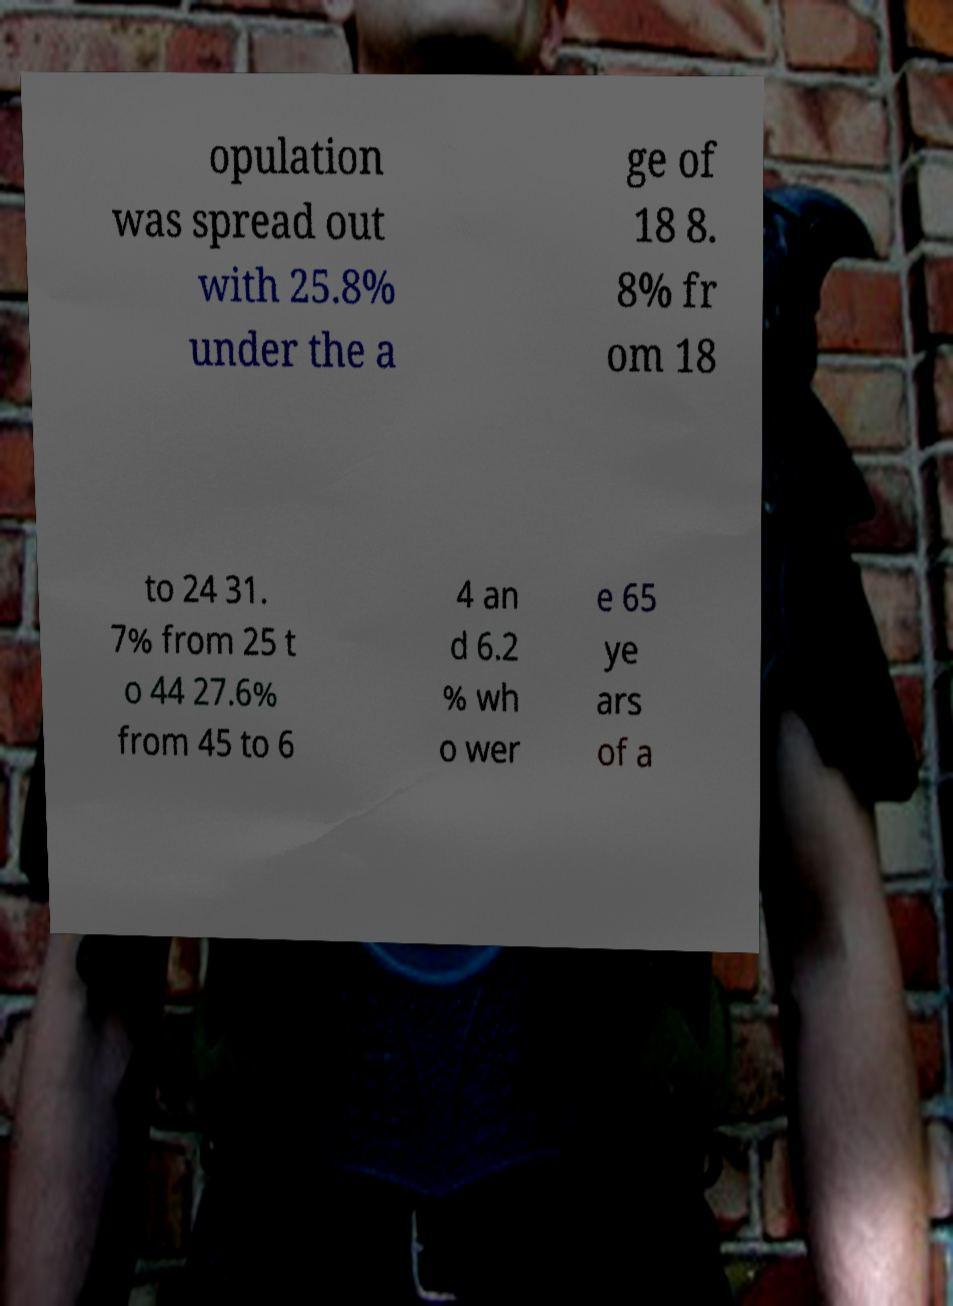For documentation purposes, I need the text within this image transcribed. Could you provide that? opulation was spread out with 25.8% under the a ge of 18 8. 8% fr om 18 to 24 31. 7% from 25 t o 44 27.6% from 45 to 6 4 an d 6.2 % wh o wer e 65 ye ars of a 